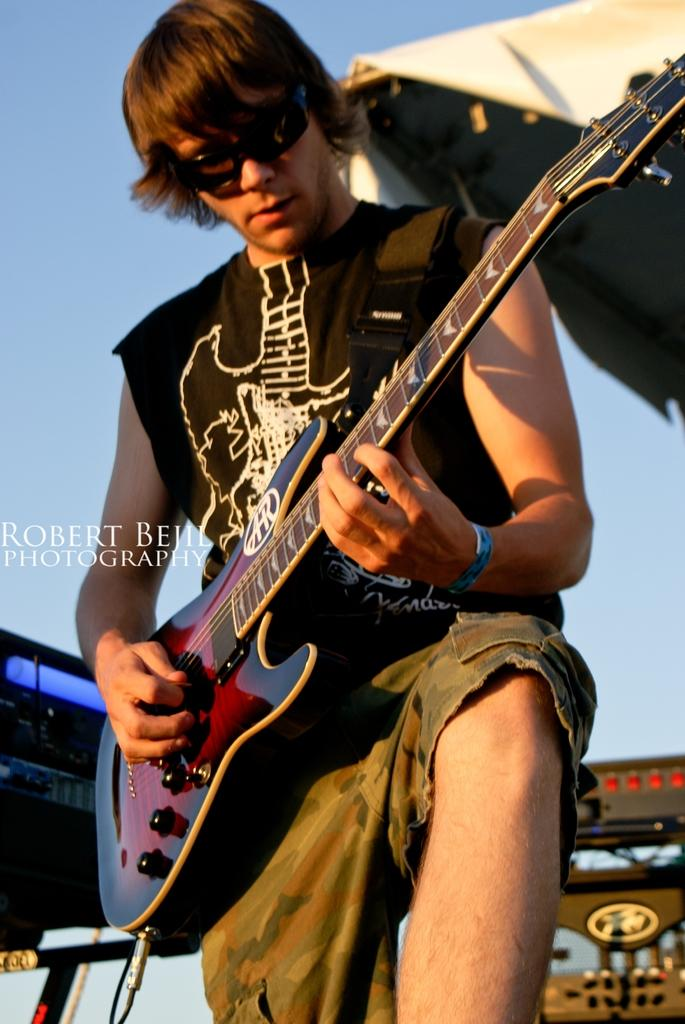Where was the image taken? The image was taken outdoors. Who is in the image? There is a man in the image. What is the man doing in the image? The man is standing and playing music. What instrument is the man playing? The man is holding a guitar and playing music with it. What can be seen in the background of the image? The sky is visible in the background of the image. What accessory is the man wearing in the image? The man is wearing shades. How many kittens are sitting on the guitar in the image? There are no kittens present in the image, and therefore none are sitting on the guitar. What type of steel is used to make the guitar in the image? There is no information about the material used to make the guitar in the image, and steel is not mentioned in the provided facts. 